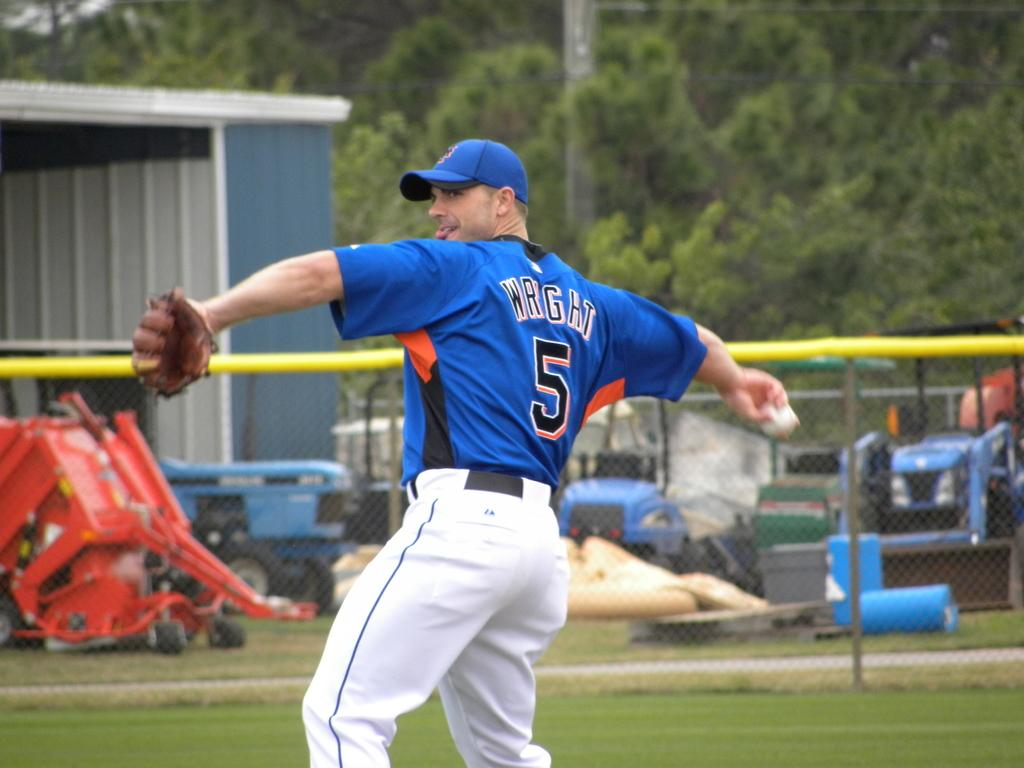<image>
Offer a succinct explanation of the picture presented. a baseball player with a blue shirt with a 5 on the back. 